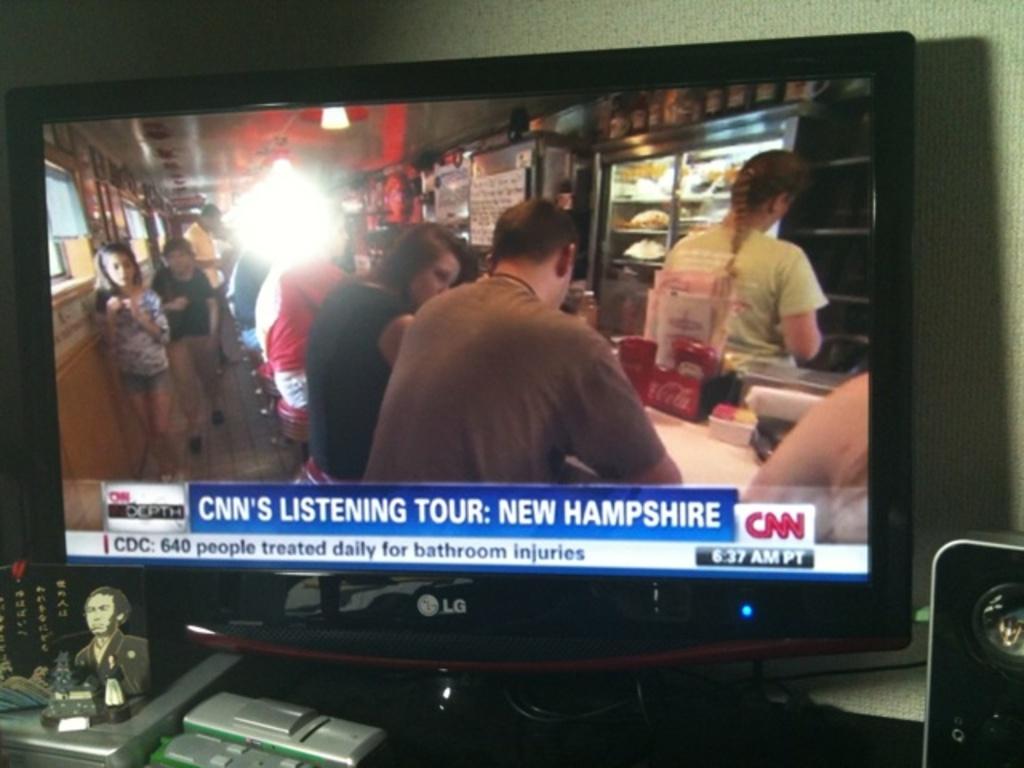What television channel is on display?
Provide a short and direct response. Cnn. 